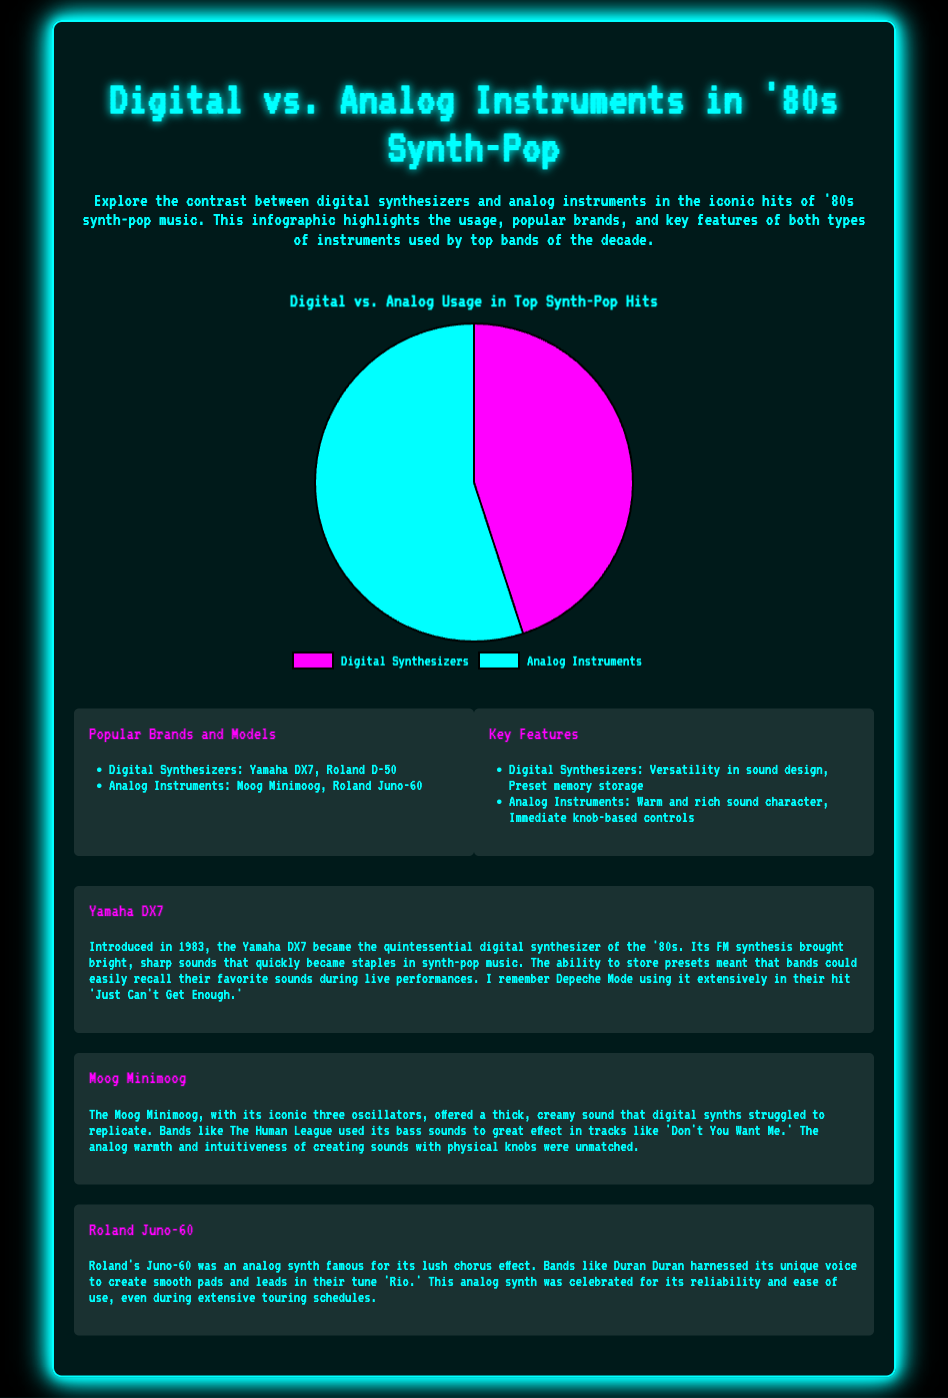what is the percentage of Analog Instruments used in top synth-pop hits? The document states that the usage of Analog Instruments is 55%.
Answer: 55% what is the percentage of Digital Synthesizers used in top synth-pop hits? The document states that the usage of Digital Synthesizers is 45%.
Answer: 45% name one popular digital synthesizer mentioned in the document. The document lists the Yamaha DX7 as a popular digital synthesizer.
Answer: Yamaha DX7 name one significant feature of digital synthesizers. The document highlights "Versatility in sound design" as a key feature of digital synthesizers.
Answer: Versatility in sound design which analog instrument is known for its thick, creamy sound? The Moog Minimoog is noted for its thick, creamy sound in the document.
Answer: Moog Minimoog which band extensively used the Yamaha DX7? Depeche Mode is mentioned as a band that extensively used the Yamaha DX7.
Answer: Depeche Mode what color represents digital synthesizers in the pie chart? The pie chart uses the color magenta to represent digital synthesizers.
Answer: Magenta what was a significant year for the introduction of the Yamaha DX7? The document specifies that the Yamaha DX7 was introduced in 1983.
Answer: 1983 what type of infographic is this document categorized as? The document is categorized as a statistical infographic.
Answer: Statistical infographic 